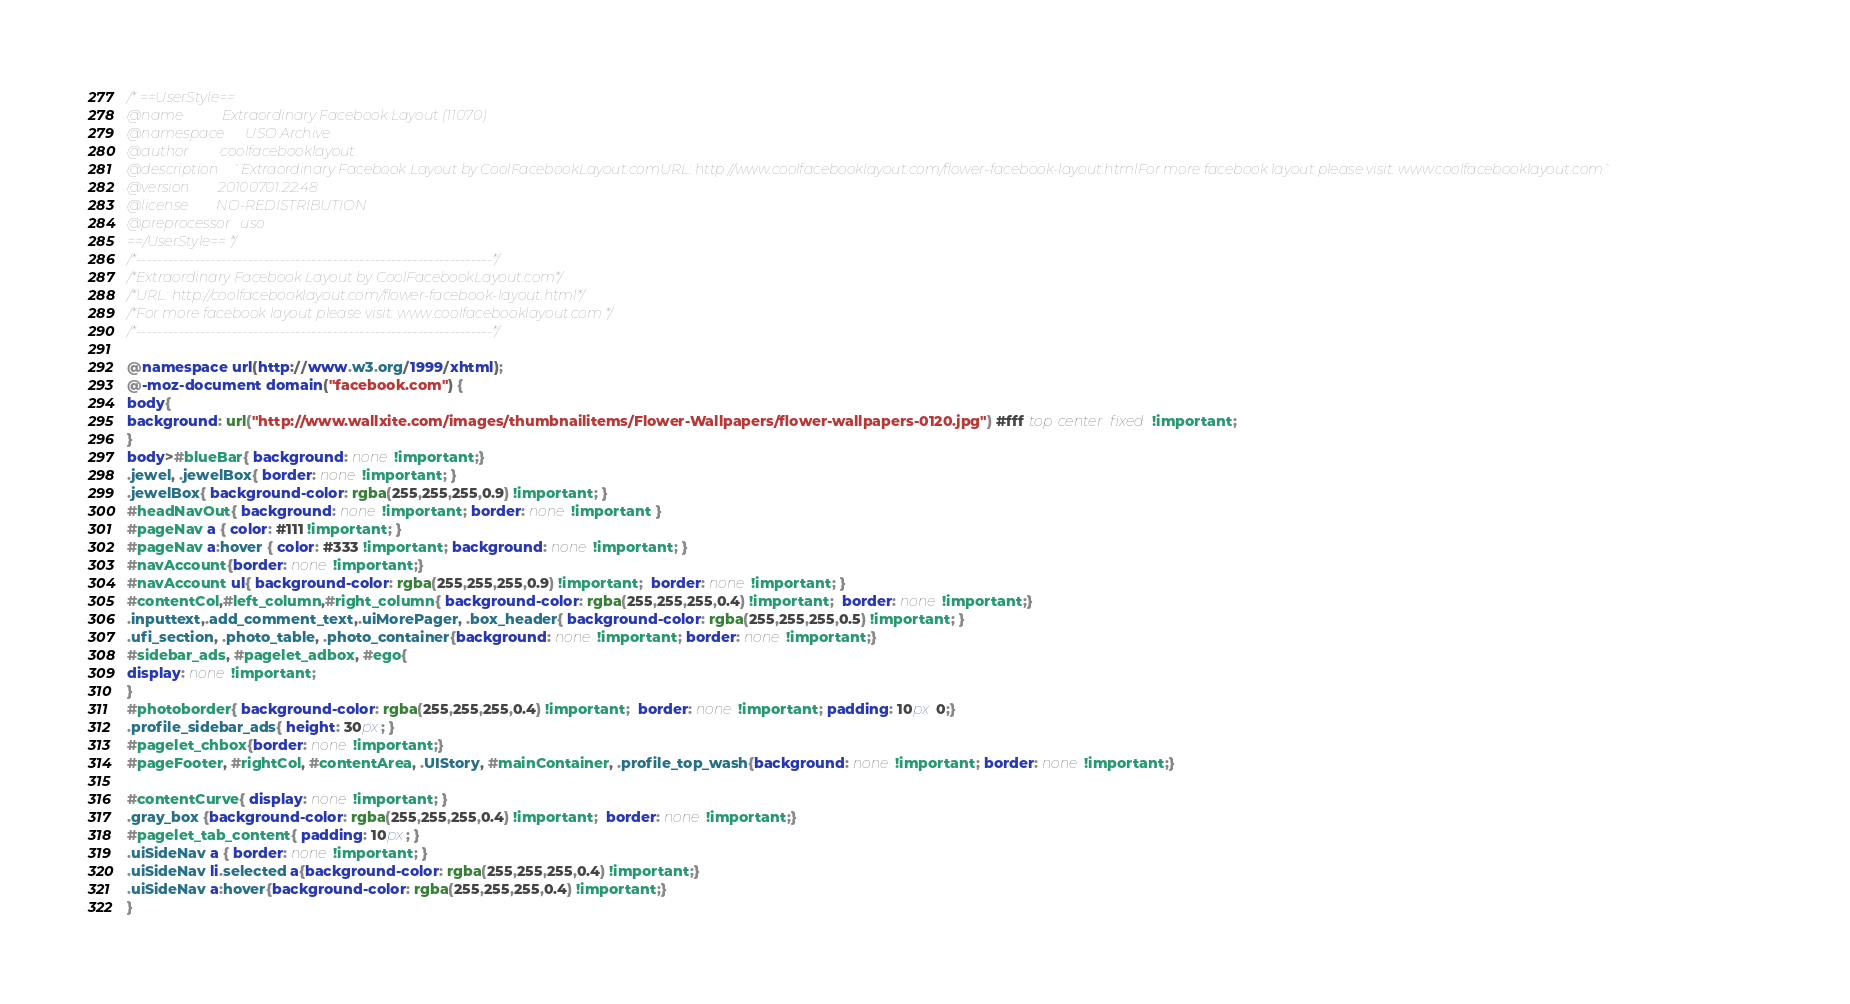<code> <loc_0><loc_0><loc_500><loc_500><_CSS_>/* ==UserStyle==
@name           Extraordinary Facebook Layout (11070)
@namespace      USO Archive
@author         coolfacebooklayout
@description    `Extraordinary Facebook Layout by CoolFacebookLayout.comURL: http://www.coolfacebooklayout.com/flower-facebook-layout.htmlFor more facebook layout please visit: www.coolfacebooklayout.com`
@version        20100701.22.48
@license        NO-REDISTRIBUTION
@preprocessor   uso
==/UserStyle== */
/*-------------------------------------------------------------------*/
/*Extraordinary Facebook Layout by CoolFacebookLayout.com*/
/*URL: http://coolfacebooklayout.com/flower-facebook-layout.html*/
/*For more facebook layout please visit: www.coolfacebooklayout.com */
/*-------------------------------------------------------------------*/

@namespace url(http://www.w3.org/1999/xhtml);
@-moz-document domain("facebook.com") {
body{
background: url("http://www.wallxite.com/images/thumbnailitems/Flower-Wallpapers/flower-wallpapers-0120.jpg") #fff top center fixed !important;
}
body>#blueBar{ background: none !important;}
.jewel, .jewelBox{ border: none !important; }
.jewelBox{ background-color: rgba(255,255,255,0.9) !important; }
#headNavOut{ background: none !important; border: none !important }
#pageNav a { color: #111 !important; }
#pageNav a:hover { color: #333 !important; background: none !important; }
#navAccount{border: none !important;}
#navAccount ul{ background-color: rgba(255,255,255,0.9) !important;  border: none !important; }
#contentCol,#left_column,#right_column{ background-color: rgba(255,255,255,0.4) !important;  border: none !important;}
.inputtext,.add_comment_text,.uiMorePager, .box_header{ background-color: rgba(255,255,255,0.5) !important; }
.ufi_section, .photo_table, .photo_container{background: none !important; border: none !important;}
#sidebar_ads, #pagelet_adbox, #ego{
display: none !important;
}
#photoborder{ background-color: rgba(255,255,255,0.4) !important;  border: none !important; padding: 10px 0;}
.profile_sidebar_ads{ height: 30px; }
#pagelet_chbox{border: none !important;}
#pageFooter, #rightCol, #contentArea, .UIStory, #mainContainer, .profile_top_wash{background: none !important; border: none !important;}

#contentCurve{ display: none !important; }
.gray_box {background-color: rgba(255,255,255,0.4) !important;  border: none !important;}
#pagelet_tab_content{ padding: 10px; }
.uiSideNav a { border: none !important; }
.uiSideNav li.selected a{background-color: rgba(255,255,255,0.4) !important;}
.uiSideNav a:hover{background-color: rgba(255,255,255,0.4) !important;}
}</code> 